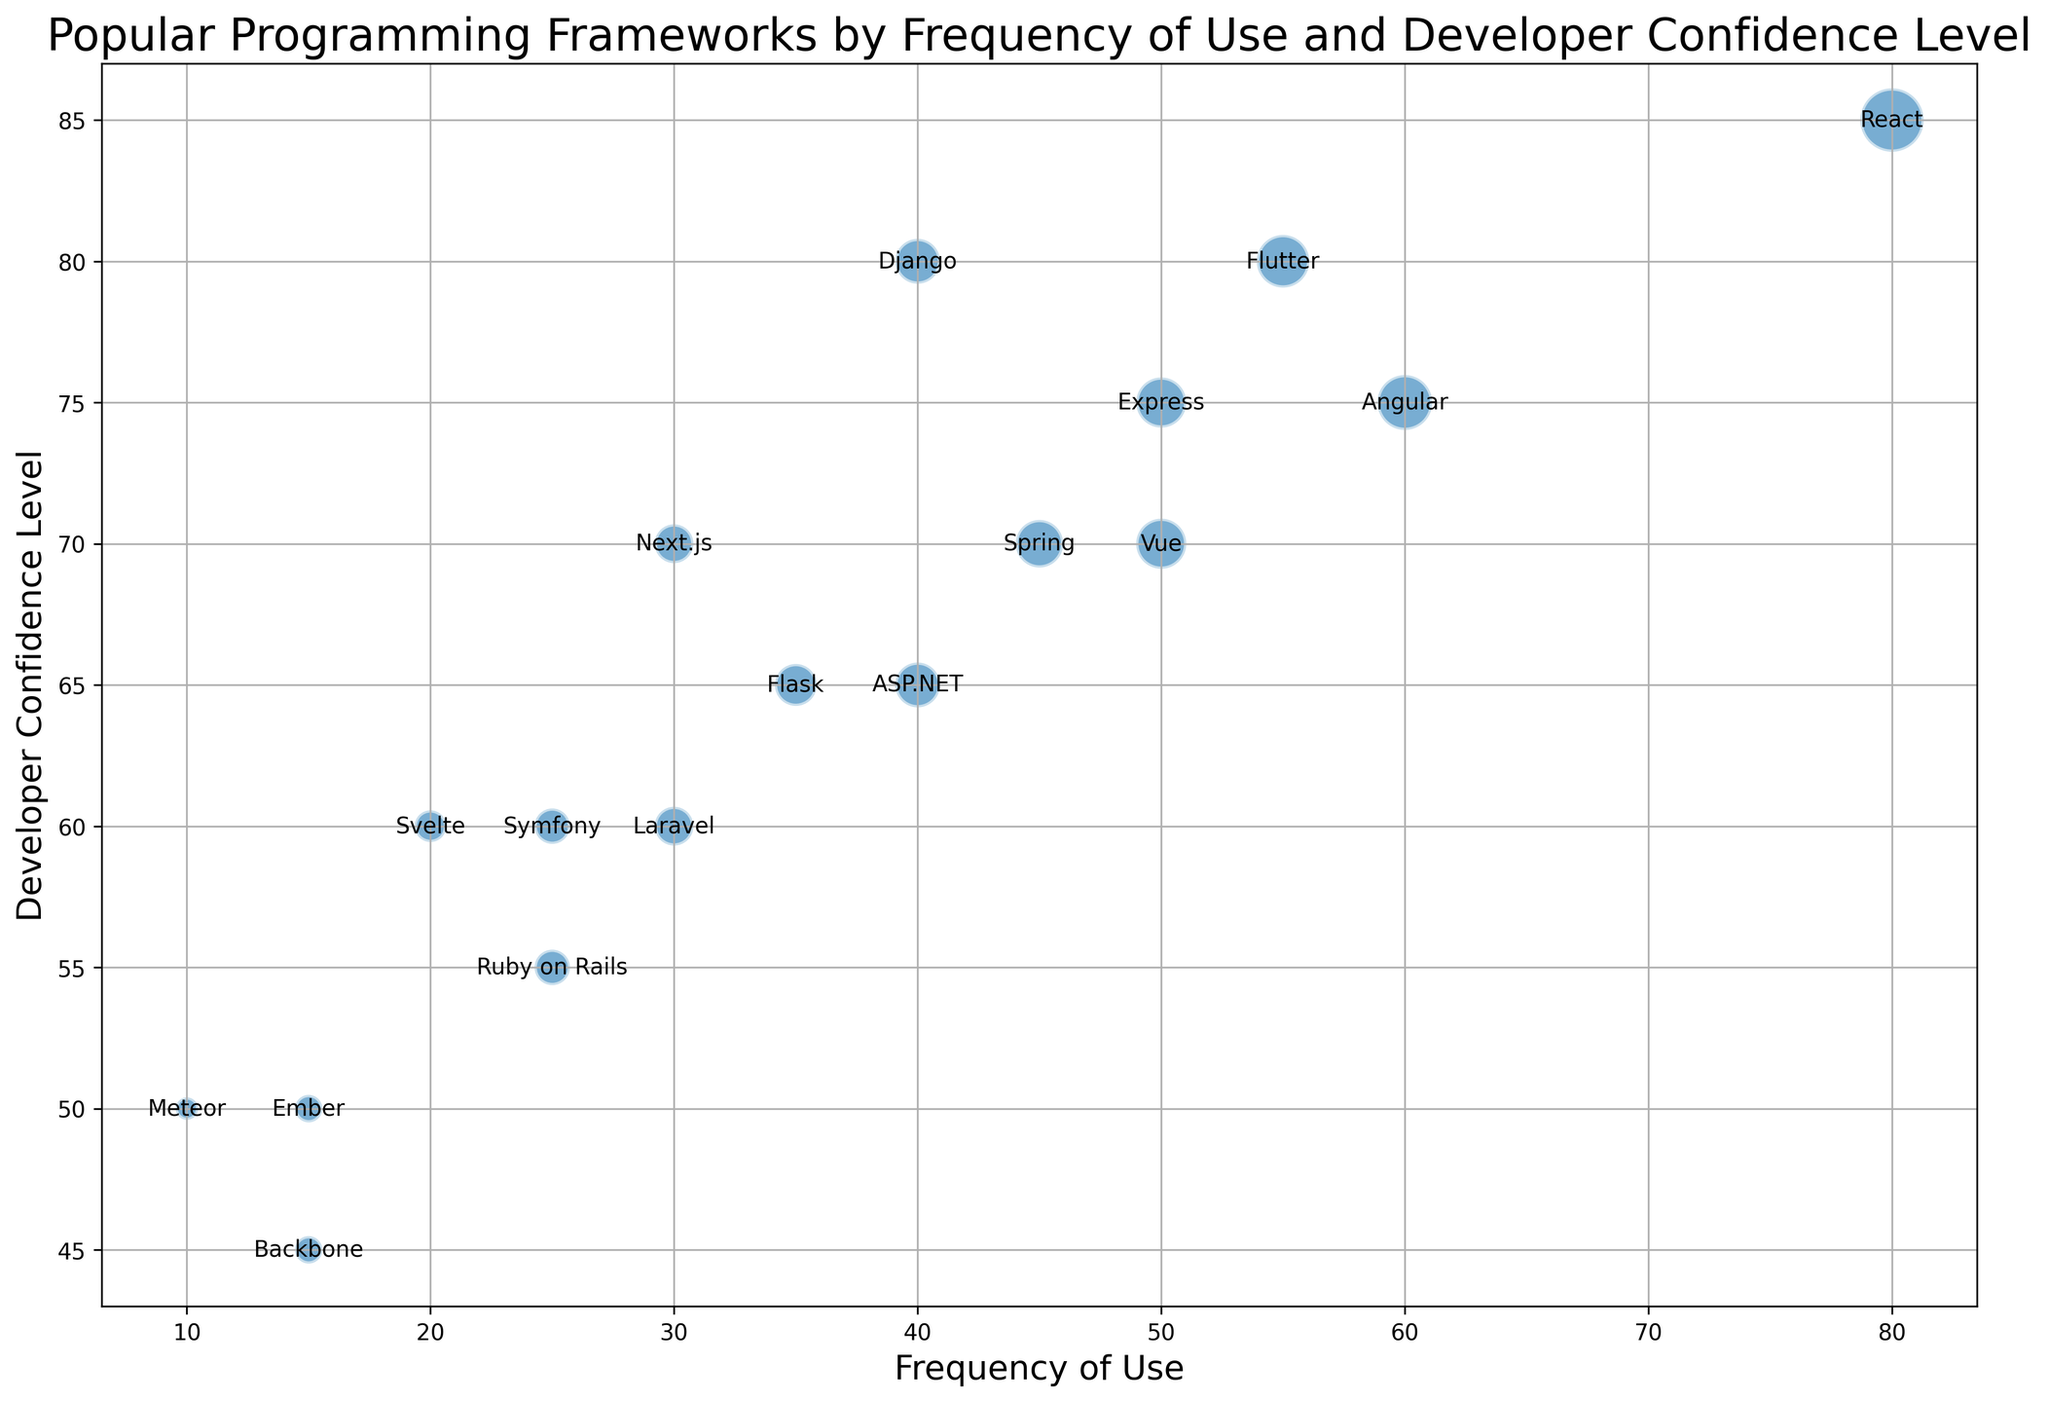What is the most frequently used programming framework? From the plot, the size and position of the bubbles indicate the frequency of use. The largest bubble corresponds to 'React' at a frequency of 80.
Answer: React Which framework has the highest developer confidence level? The vertical position of bubbles indicates the developer confidence level. The highest bubble is 'React' with a level of 85.
Answer: React Which framework has the lowest frequency of use? The smallest bubble in the plot at the far left is 'Meteor' with a frequency of use of 10.
Answer: Meteor Which framework is used more frequently, Angular or Vue? Comparing the horizontal positions of the bubbles for Angular and Vue, Angular has a frequency of 60, while Vue has 50.
Answer: Angular What framework has the same frequency of use as Django but a different confidence level? The bubble for Django at frequency 40 has the same frequency as ASP.NET, but the bubbles are at different vertical positions (confidence level Django: 80, ASP.NET: 65).
Answer: ASP.NET Between Flask and React, which framework has a higher confidence level? Comparing the vertical positions of Flask (65) and React (85), React has a higher confidence level.
Answer: React What is the combined frequency of use for frameworks Angular, Vue, and Django? Sum the frequency of use for Angular (60), Vue (50), and Django (40), which equals 60 + 50 + 40 = 150.
Answer: 150 What is the difference in developer confidence level between Flask and Laravel? Flask has a confidence level of 65, and Laravel has 60. The difference is 65 - 60 = 5.
Answer: 5 Which framework has similar rates of use but different confidence levels compared to Express? Express at 50 usage rate can be compared in bubble position with Vue at the same frequency but different confidence (Vue: 70, Express: 75).
Answer: Vue What is the average developer confidence level of React, Angular, and Vue? Calculate the average of confidence levels of React (85), Angular (75), and Vue (70), (85 + 75 + 70) / 3 = 76.67
Answer: 76.67 